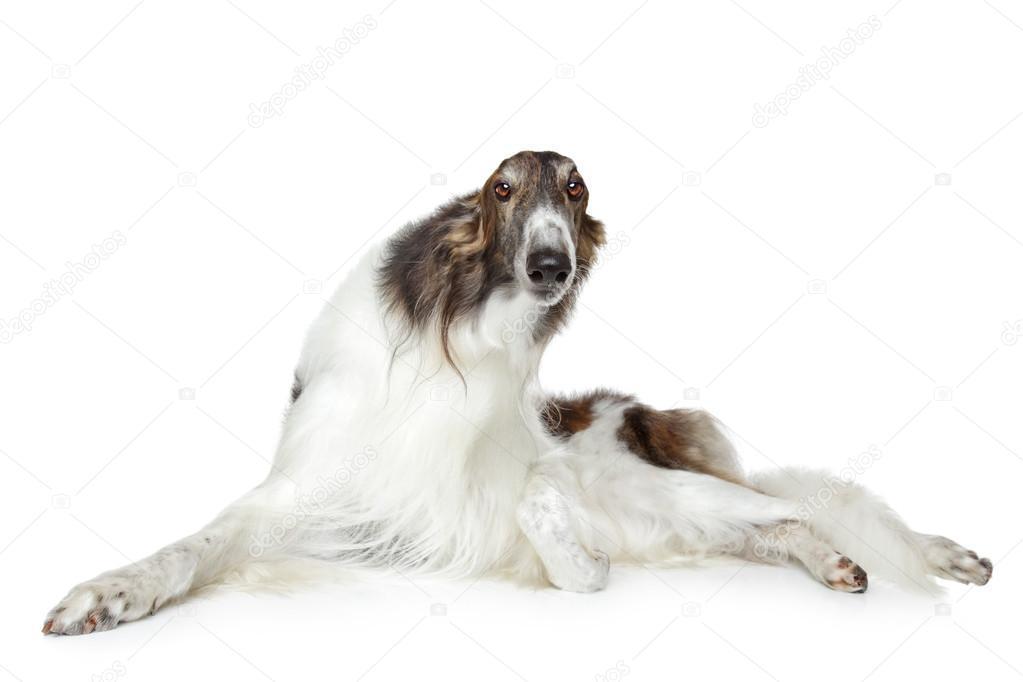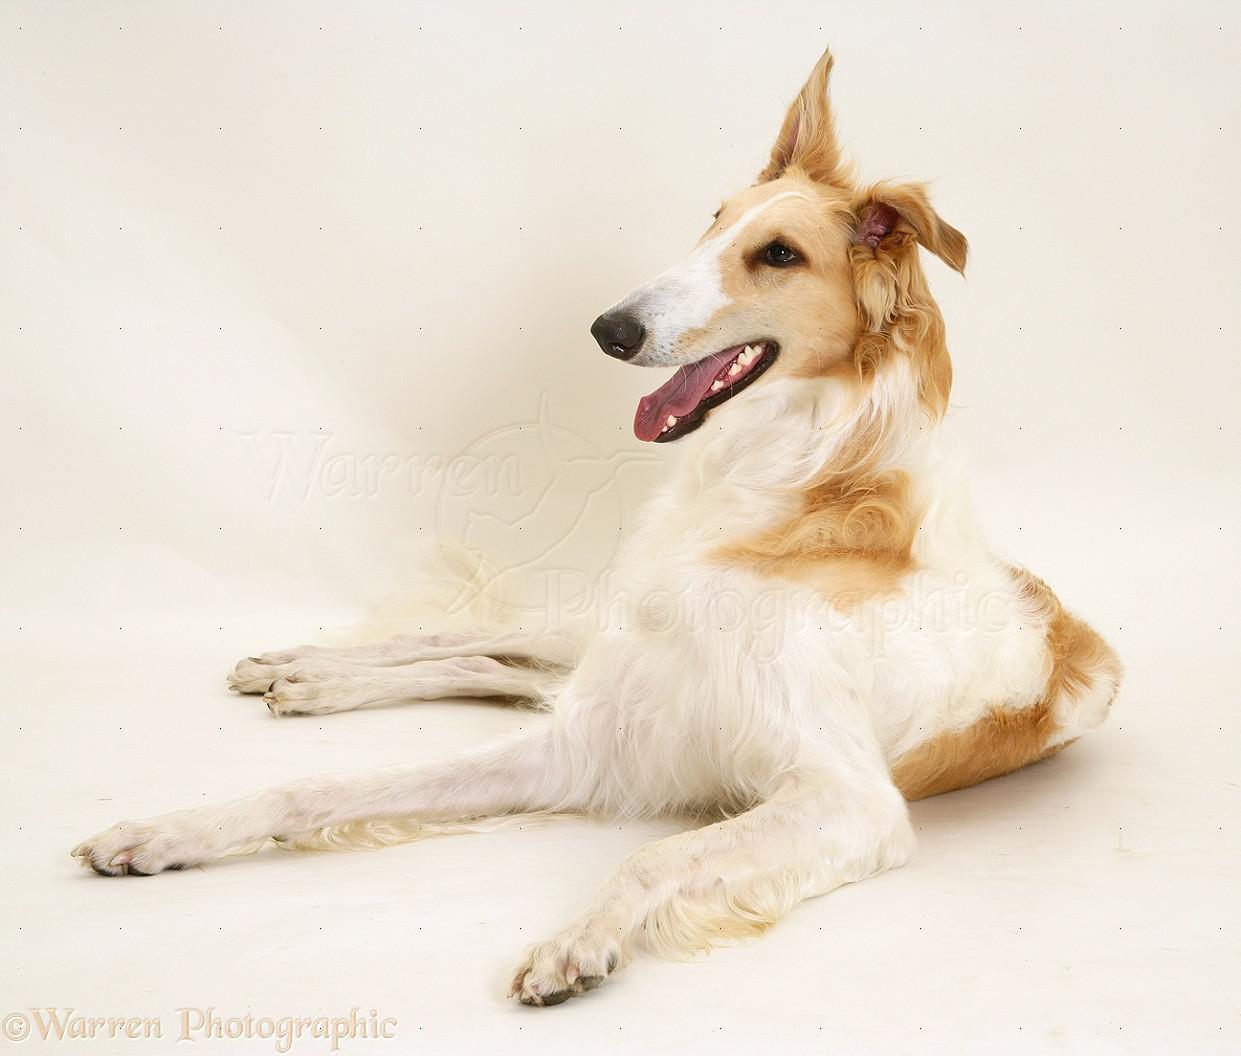The first image is the image on the left, the second image is the image on the right. For the images shown, is this caption "Each image contains a single hound dog, and one image shows a dog in a reclining position with both front paws extended forward." true? Answer yes or no. Yes. The first image is the image on the left, the second image is the image on the right. Considering the images on both sides, is "The dog in the image on the right is lying down." valid? Answer yes or no. Yes. 